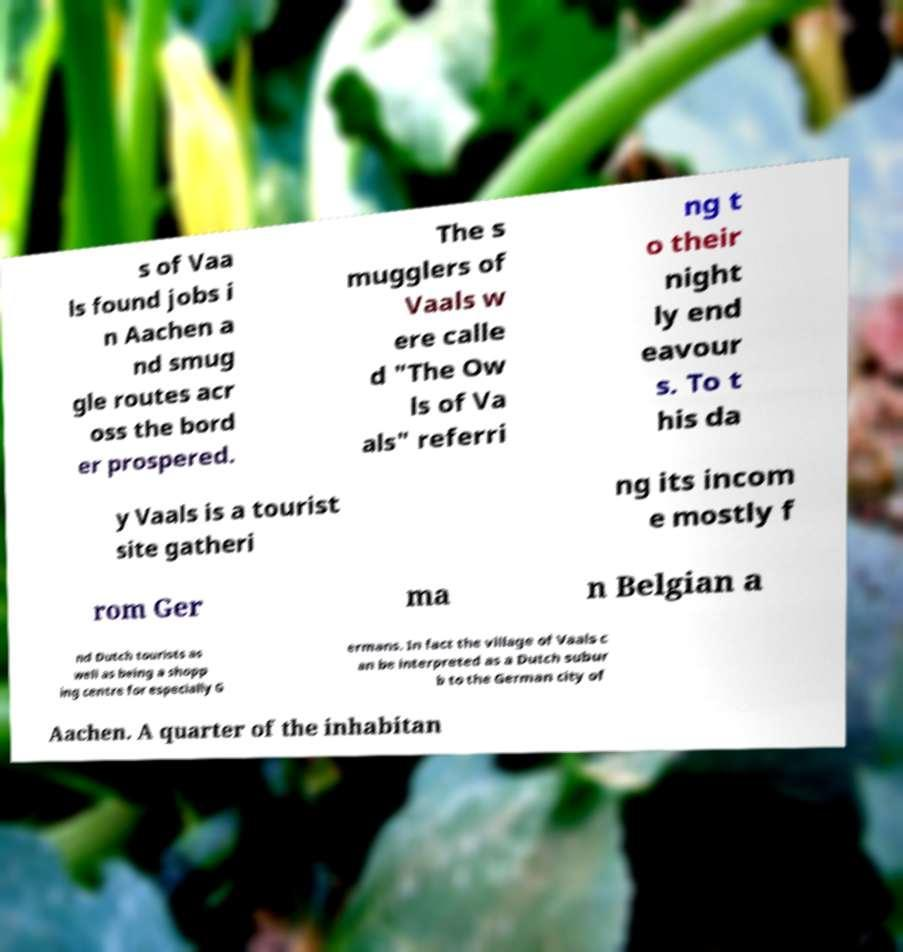For documentation purposes, I need the text within this image transcribed. Could you provide that? s of Vaa ls found jobs i n Aachen a nd smug gle routes acr oss the bord er prospered. The s mugglers of Vaals w ere calle d "The Ow ls of Va als" referri ng t o their night ly end eavour s. To t his da y Vaals is a tourist site gatheri ng its incom e mostly f rom Ger ma n Belgian a nd Dutch tourists as well as being a shopp ing centre for especially G ermans. In fact the village of Vaals c an be interpreted as a Dutch subur b to the German city of Aachen. A quarter of the inhabitan 